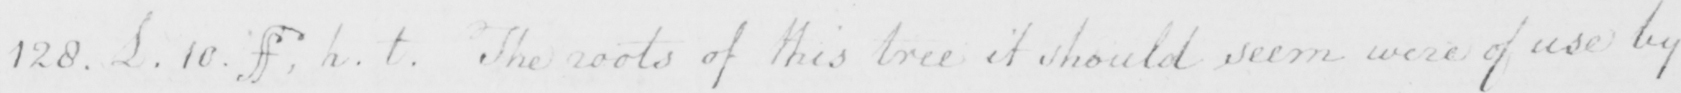Please provide the text content of this handwritten line. 128 . L . 10 ff , h . t . The roots of this tree it should seem were of use by 